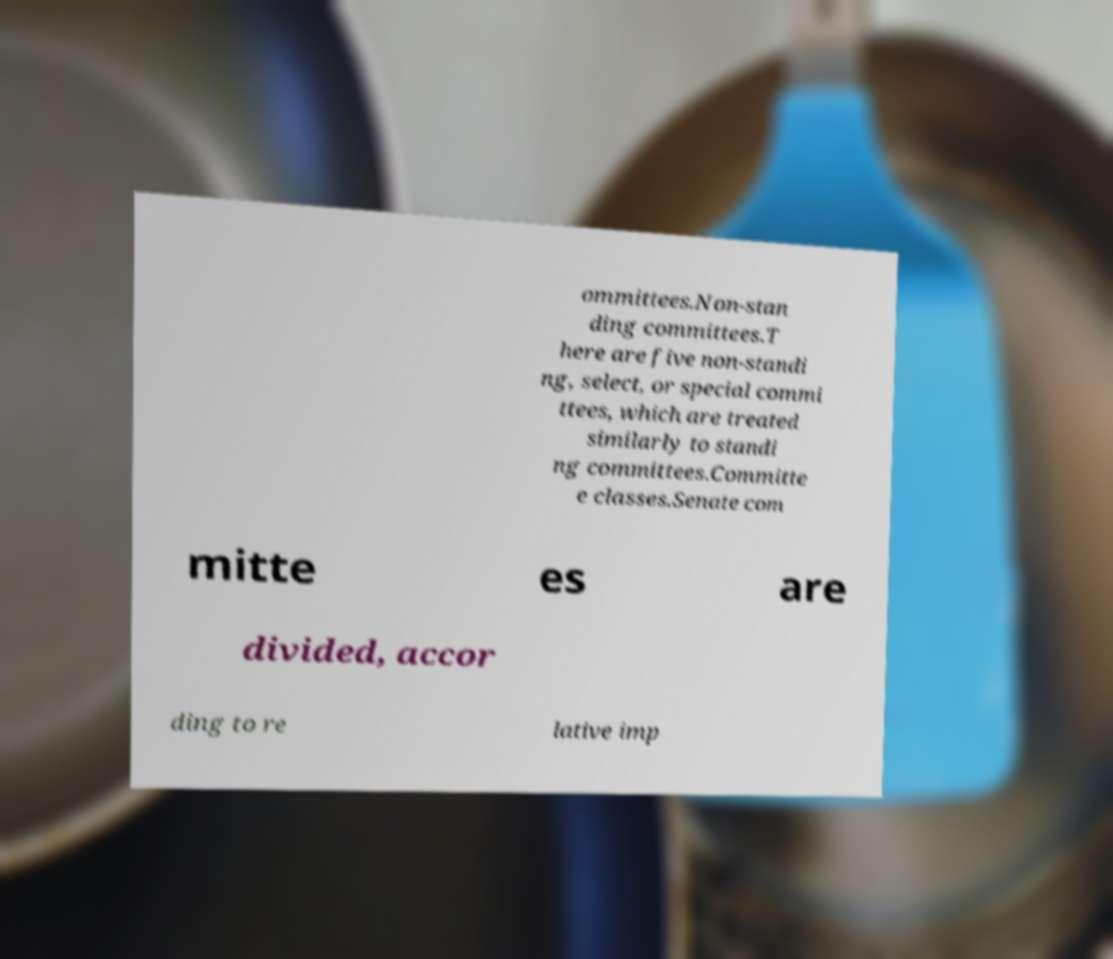I need the written content from this picture converted into text. Can you do that? ommittees.Non-stan ding committees.T here are five non-standi ng, select, or special commi ttees, which are treated similarly to standi ng committees.Committe e classes.Senate com mitte es are divided, accor ding to re lative imp 